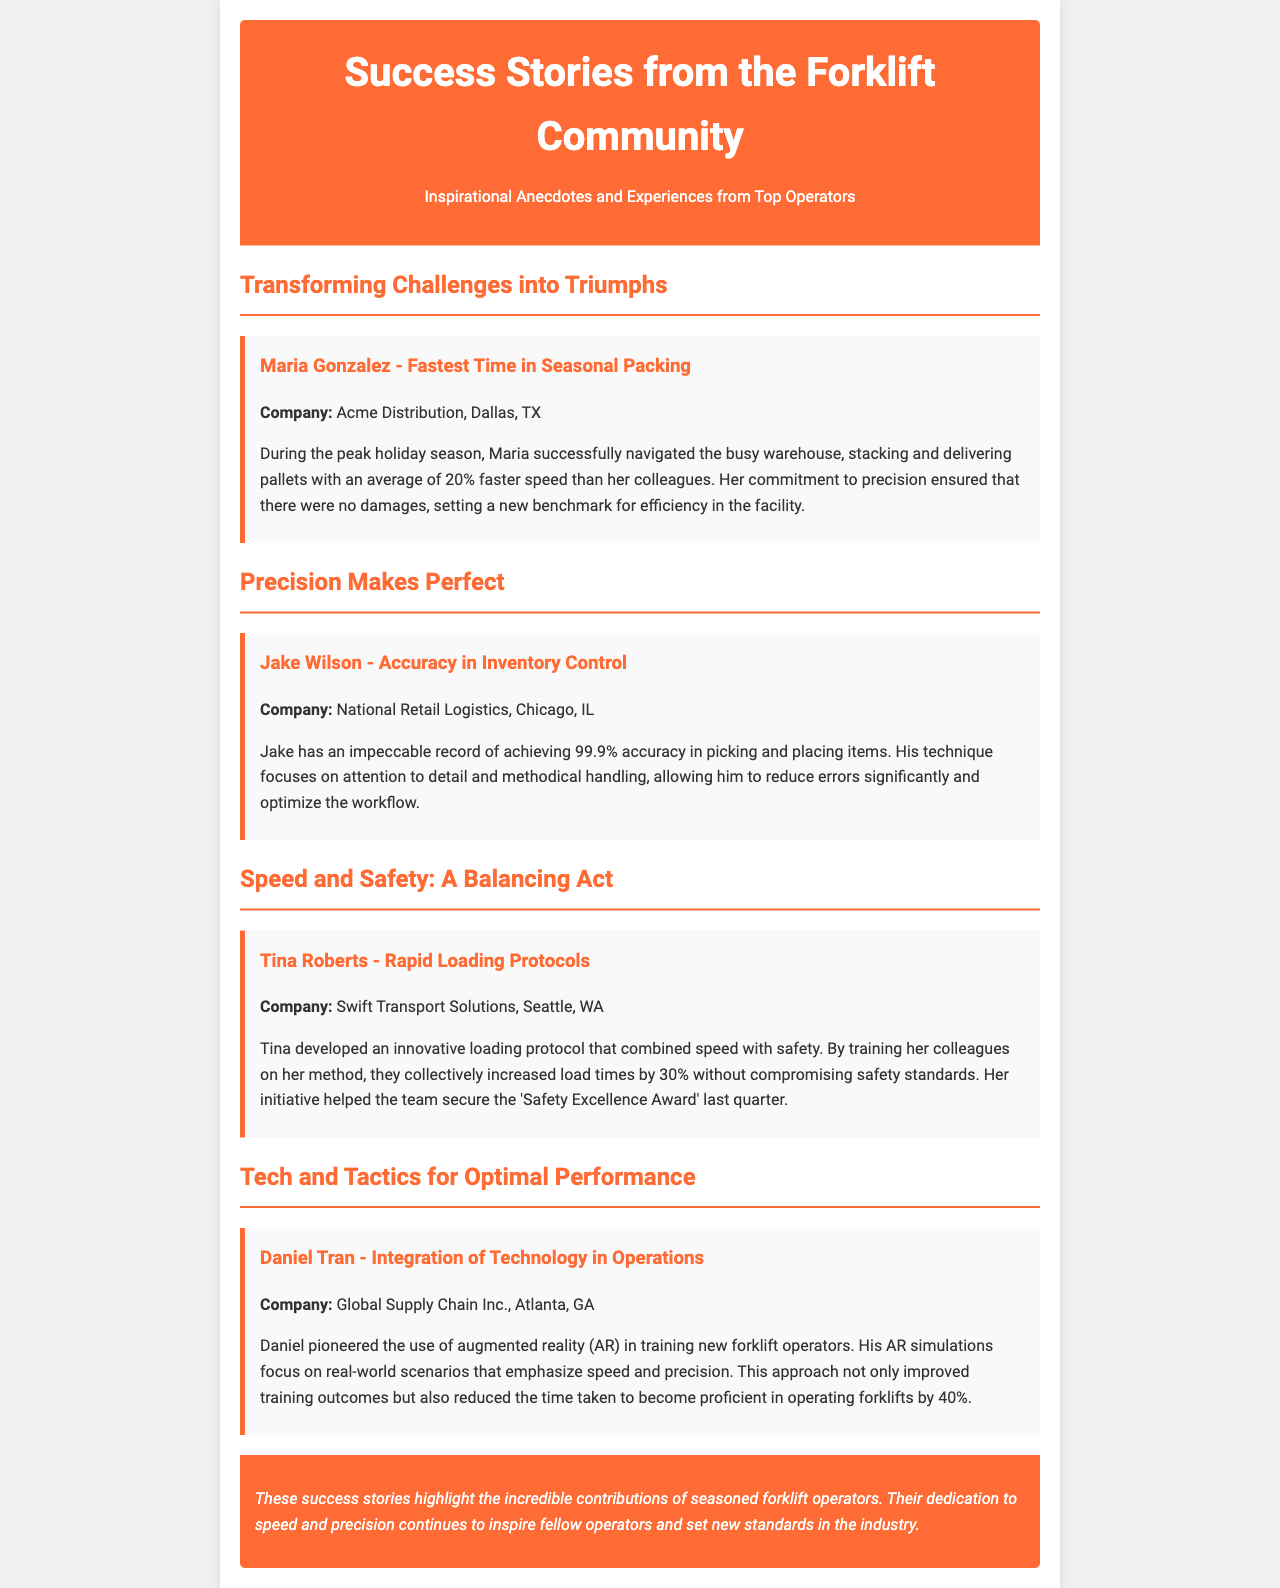What is Maria Gonzalez known for? Maria Gonzalez is known for achieving the fastest time in seasonal packing at Acme Distribution.
Answer: Fastest Time in Seasonal Packing What was Jake Wilson's accuracy percentage? Jake Wilson achieved an accuracy percentage of 99.9% in picking and placing items.
Answer: 99.9% How much faster was Maria compared to her colleagues? Maria operated with an average speed that was 20% faster than her colleagues during the peak holiday season.
Answer: 20% Which award did Tina's team secure? Tina's team secured the 'Safety Excellence Award' last quarter due to their improved loading protocols.
Answer: Safety Excellence Award What technology did Daniel Tran introduce in training? Daniel Tran introduced the use of augmented reality (AR) in training new forklift operators.
Answer: Augmented reality (AR) How much did Tina increase load times by? Tina's innovative loading protocol increased load times by 30%.
Answer: 30% What company does Daniel Tran work for? Daniel Tran works for Global Supply Chain Inc. in Atlanta, GA.
Answer: Global Supply Chain Inc What industry standard do these success stories aim to inspire? The success stories aim to inspire standards in speed and precision within the forklift community.
Answer: Speed and precision 